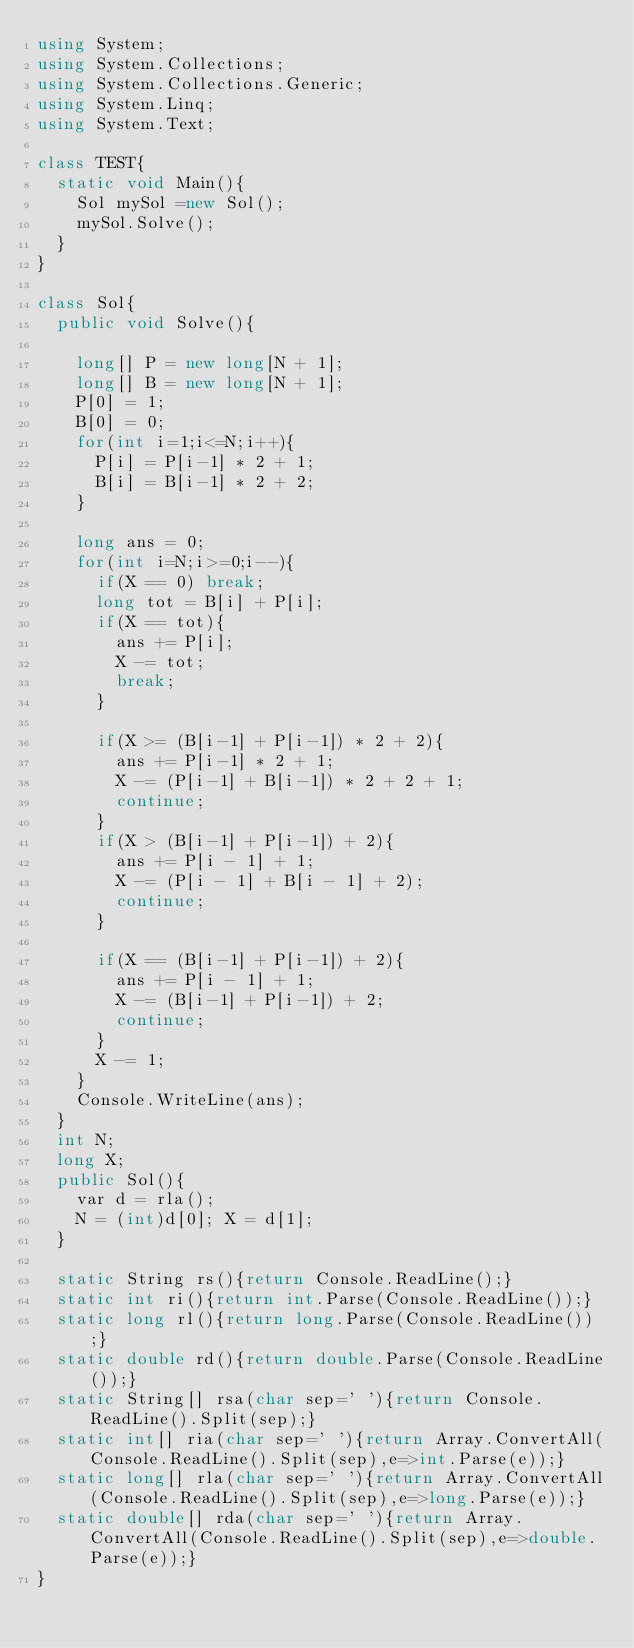<code> <loc_0><loc_0><loc_500><loc_500><_C#_>using System;
using System.Collections;
using System.Collections.Generic;
using System.Linq;
using System.Text;

class TEST{
	static void Main(){
		Sol mySol =new Sol();
		mySol.Solve();
	}
}

class Sol{
	public void Solve(){
		
		long[] P = new long[N + 1];
		long[] B = new long[N + 1];
		P[0] = 1;
		B[0] = 0;
		for(int i=1;i<=N;i++){
			P[i] = P[i-1] * 2 + 1;
			B[i] = B[i-1] * 2 + 2;
		}
		
		long ans = 0;
		for(int i=N;i>=0;i--){
			if(X == 0) break;
			long tot = B[i] + P[i];
			if(X == tot){
				ans += P[i];
				X -= tot;
				break;
			}
			
			if(X >= (B[i-1] + P[i-1]) * 2 + 2){
				ans += P[i-1] * 2 + 1;
				X -= (P[i-1] + B[i-1]) * 2 + 2 + 1;
				continue;
			}
			if(X > (B[i-1] + P[i-1]) + 2){
				ans += P[i - 1] + 1;
				X -= (P[i - 1] + B[i - 1] + 2);
				continue;
			}
			
			if(X == (B[i-1] + P[i-1]) + 2){
				ans += P[i - 1] + 1;
				X -= (B[i-1] + P[i-1]) + 2;
				continue;
			}
			X -= 1;
		}
		Console.WriteLine(ans);
	}
	int N;
	long X;
	public Sol(){
		var d = rla();
		N = (int)d[0]; X = d[1];
	}

	static String rs(){return Console.ReadLine();}
	static int ri(){return int.Parse(Console.ReadLine());}
	static long rl(){return long.Parse(Console.ReadLine());}
	static double rd(){return double.Parse(Console.ReadLine());}
	static String[] rsa(char sep=' '){return Console.ReadLine().Split(sep);}
	static int[] ria(char sep=' '){return Array.ConvertAll(Console.ReadLine().Split(sep),e=>int.Parse(e));}
	static long[] rla(char sep=' '){return Array.ConvertAll(Console.ReadLine().Split(sep),e=>long.Parse(e));}
	static double[] rda(char sep=' '){return Array.ConvertAll(Console.ReadLine().Split(sep),e=>double.Parse(e));}
}
</code> 